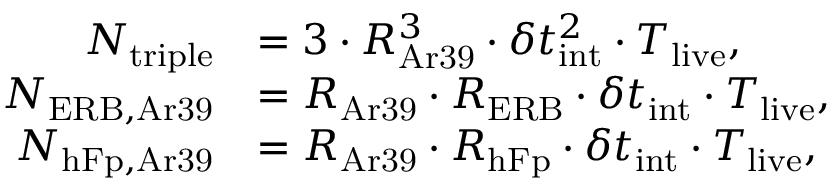Convert formula to latex. <formula><loc_0><loc_0><loc_500><loc_500>\begin{array} { r l } { N _ { t r i p l e } } & { = 3 \cdot R _ { A r 3 9 } ^ { 3 } \cdot \delta t _ { i n t } ^ { 2 } \cdot T _ { l i v e } , } \\ { N _ { E R B , A r 3 9 } } & { = R _ { A r 3 9 } \cdot R _ { E R B } \cdot \delta t _ { i n t } \cdot T _ { l i v e } , } \\ { N _ { h F p , A r 3 9 } } & { = R _ { A r 3 9 } \cdot R _ { h F p } \cdot \delta t _ { i n t } \cdot T _ { l i v e } , } \end{array}</formula> 